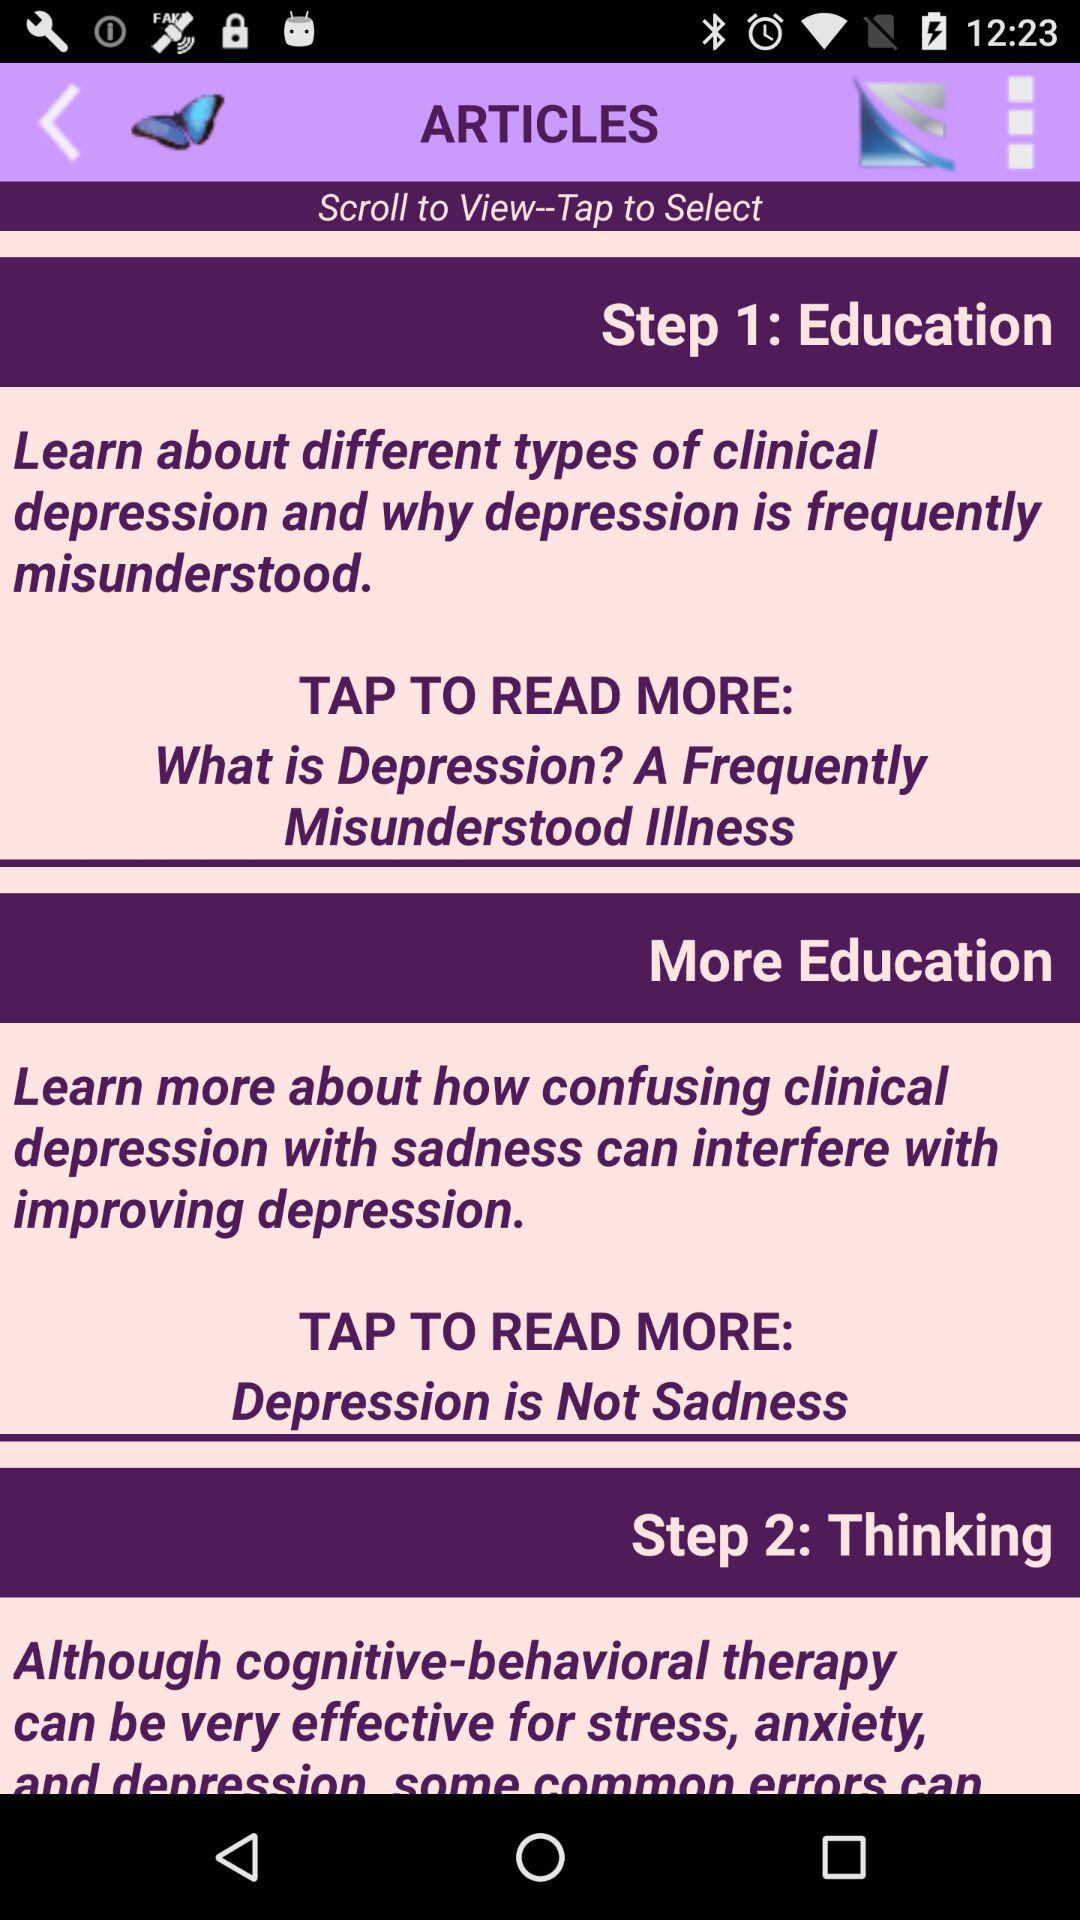Which step of the article has the title "Thinking"? The step of the article that has the title "Thinking" is 2. 